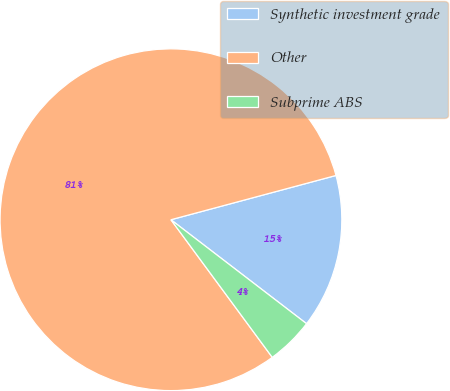Convert chart to OTSL. <chart><loc_0><loc_0><loc_500><loc_500><pie_chart><fcel>Synthetic investment grade<fcel>Other<fcel>Subprime ABS<nl><fcel>14.58%<fcel>80.93%<fcel>4.49%<nl></chart> 